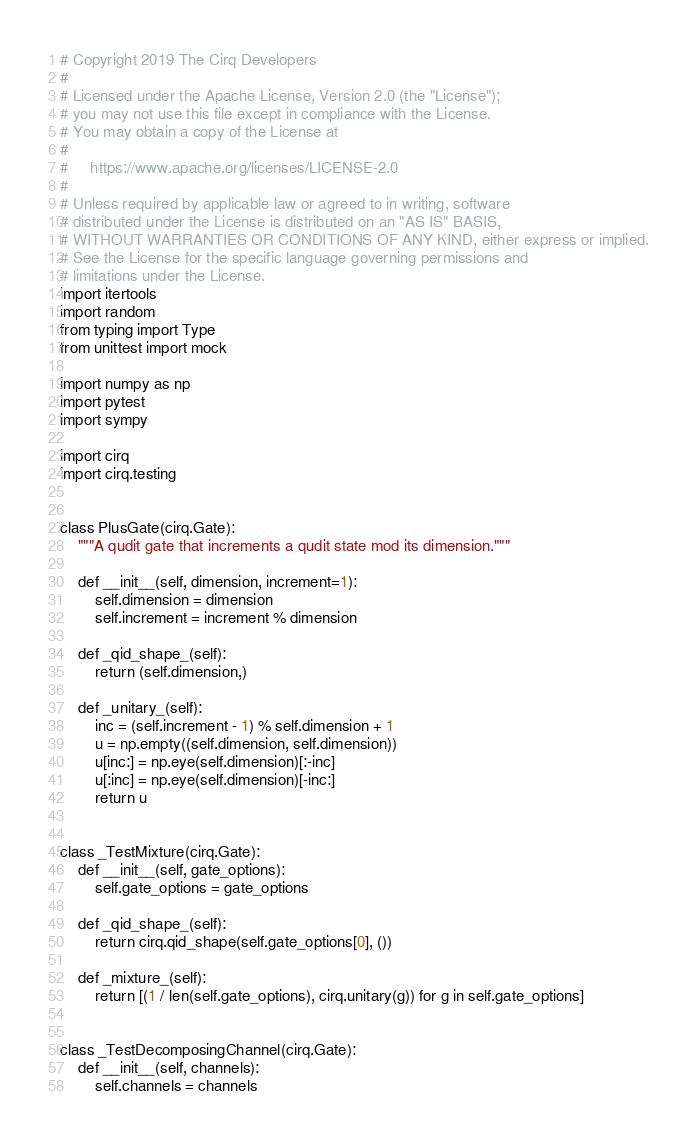<code> <loc_0><loc_0><loc_500><loc_500><_Python_># Copyright 2019 The Cirq Developers
#
# Licensed under the Apache License, Version 2.0 (the "License");
# you may not use this file except in compliance with the License.
# You may obtain a copy of the License at
#
#     https://www.apache.org/licenses/LICENSE-2.0
#
# Unless required by applicable law or agreed to in writing, software
# distributed under the License is distributed on an "AS IS" BASIS,
# WITHOUT WARRANTIES OR CONDITIONS OF ANY KIND, either express or implied.
# See the License for the specific language governing permissions and
# limitations under the License.
import itertools
import random
from typing import Type
from unittest import mock

import numpy as np
import pytest
import sympy

import cirq
import cirq.testing


class PlusGate(cirq.Gate):
    """A qudit gate that increments a qudit state mod its dimension."""

    def __init__(self, dimension, increment=1):
        self.dimension = dimension
        self.increment = increment % dimension

    def _qid_shape_(self):
        return (self.dimension,)

    def _unitary_(self):
        inc = (self.increment - 1) % self.dimension + 1
        u = np.empty((self.dimension, self.dimension))
        u[inc:] = np.eye(self.dimension)[:-inc]
        u[:inc] = np.eye(self.dimension)[-inc:]
        return u


class _TestMixture(cirq.Gate):
    def __init__(self, gate_options):
        self.gate_options = gate_options

    def _qid_shape_(self):
        return cirq.qid_shape(self.gate_options[0], ())

    def _mixture_(self):
        return [(1 / len(self.gate_options), cirq.unitary(g)) for g in self.gate_options]


class _TestDecomposingChannel(cirq.Gate):
    def __init__(self, channels):
        self.channels = channels
</code> 